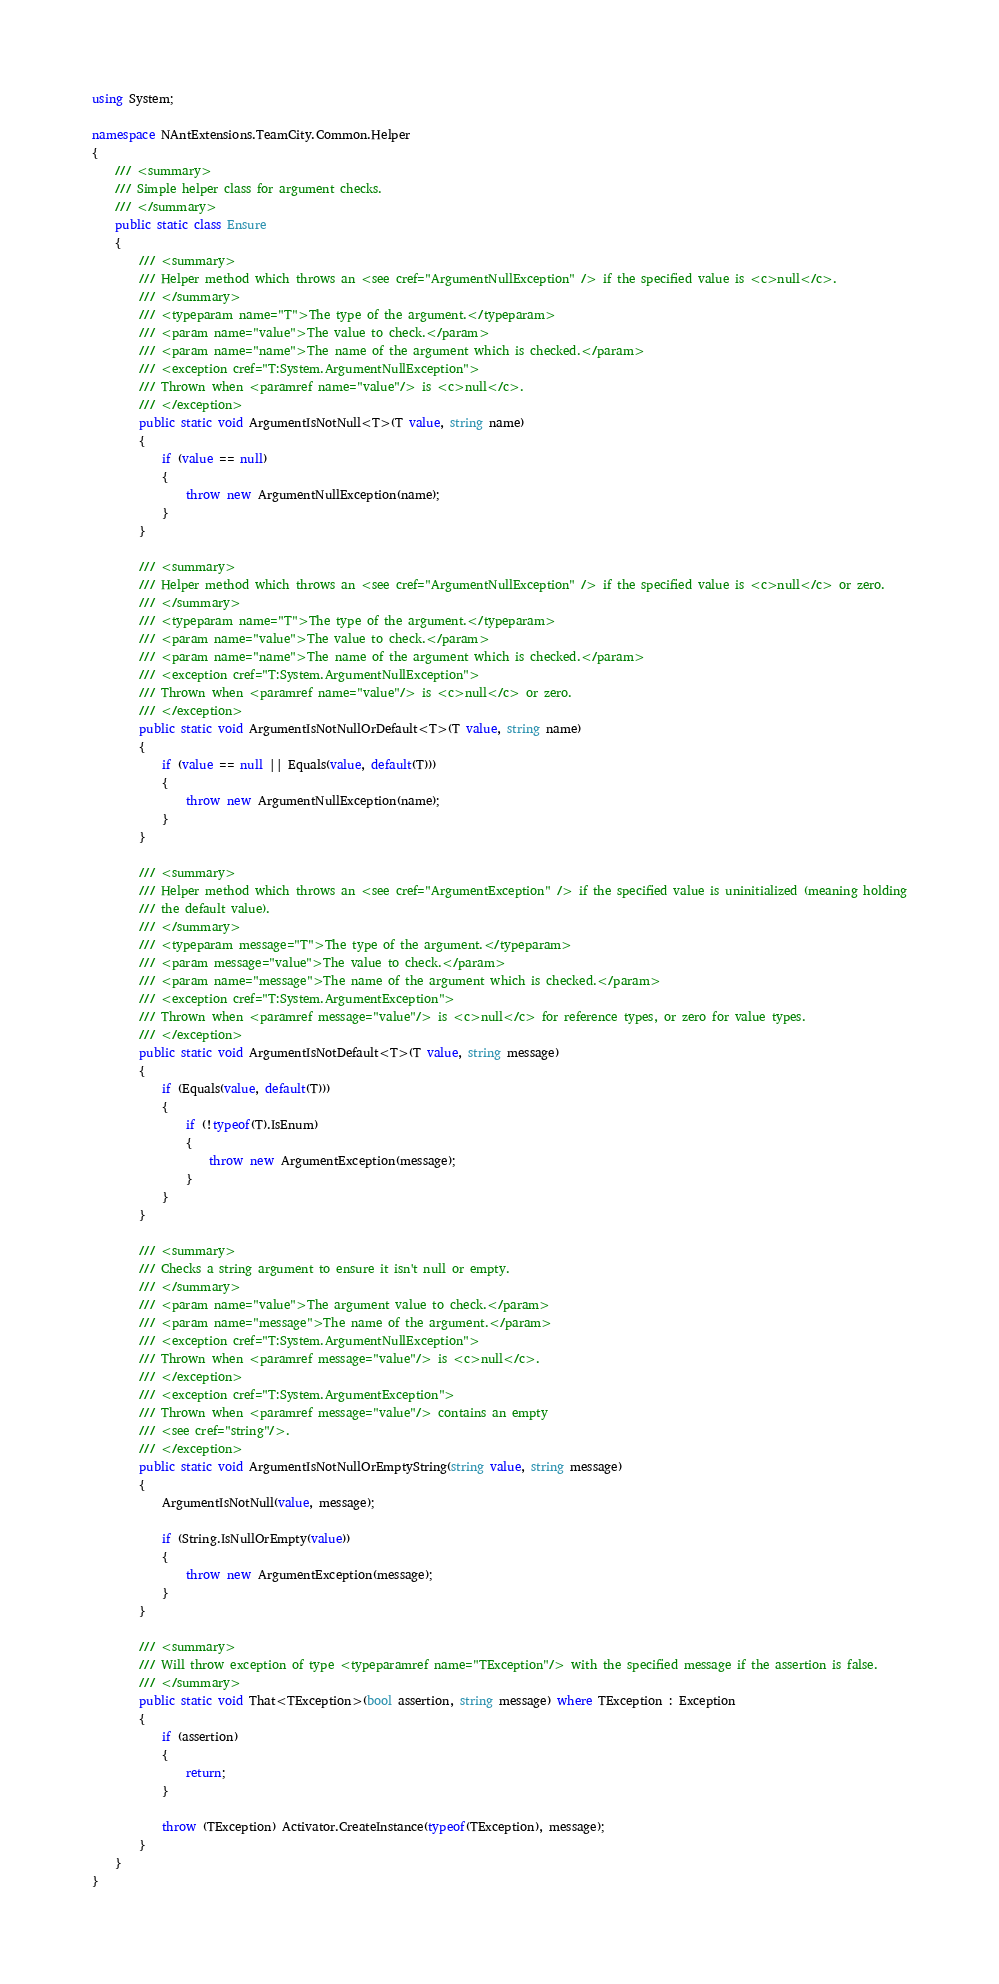<code> <loc_0><loc_0><loc_500><loc_500><_C#_>using System;

namespace NAntExtensions.TeamCity.Common.Helper
{
	/// <summary>
	/// Simple helper class for argument checks.
	/// </summary>
	public static class Ensure
	{
		/// <summary>
		/// Helper method which throws an <see cref="ArgumentNullException" /> if the specified value is <c>null</c>.
		/// </summary>
		/// <typeparam name="T">The type of the argument.</typeparam>
		/// <param name="value">The value to check.</param>
		/// <param name="name">The name of the argument which is checked.</param>
		/// <exception cref="T:System.ArgumentNullException">
		/// Thrown when <paramref name="value"/> is <c>null</c>.
		/// </exception>
		public static void ArgumentIsNotNull<T>(T value, string name)
		{
			if (value == null)
			{
				throw new ArgumentNullException(name);
			}
		}

		/// <summary>
		/// Helper method which throws an <see cref="ArgumentNullException" /> if the specified value is <c>null</c> or zero.
		/// </summary>
		/// <typeparam name="T">The type of the argument.</typeparam>
		/// <param name="value">The value to check.</param>
		/// <param name="name">The name of the argument which is checked.</param>
		/// <exception cref="T:System.ArgumentNullException">
		/// Thrown when <paramref name="value"/> is <c>null</c> or zero.
		/// </exception>
		public static void ArgumentIsNotNullOrDefault<T>(T value, string name)
		{
			if (value == null || Equals(value, default(T)))
			{
				throw new ArgumentNullException(name);
			}
		}

		/// <summary>
		/// Helper method which throws an <see cref="ArgumentException" /> if the specified value is uninitialized (meaning holding
		/// the default value).
		/// </summary>
		/// <typeparam message="T">The type of the argument.</typeparam>
		/// <param message="value">The value to check.</param>
		/// <param name="message">The name of the argument which is checked.</param>
		/// <exception cref="T:System.ArgumentException">
		/// Thrown when <paramref message="value"/> is <c>null</c> for reference types, or zero for value types.
		/// </exception>
		public static void ArgumentIsNotDefault<T>(T value, string message)
		{
			if (Equals(value, default(T)))
			{
				if (!typeof(T).IsEnum)
				{
					throw new ArgumentException(message);
				}
			}
		}

		/// <summary>
		/// Checks a string argument to ensure it isn't null or empty.
		/// </summary>
		/// <param name="value">The argument value to check.</param>
		/// <param name="message">The name of the argument.</param>
		/// <exception cref="T:System.ArgumentNullException">
		/// Thrown when <paramref message="value"/> is <c>null</c>.
		/// </exception>
		/// <exception cref="T:System.ArgumentException">
		/// Thrown when <paramref message="value"/> contains an empty 
		/// <see cref="string"/>.
		/// </exception>
		public static void ArgumentIsNotNullOrEmptyString(string value, string message)
		{
			ArgumentIsNotNull(value, message);

			if (String.IsNullOrEmpty(value))
			{
				throw new ArgumentException(message);
			}
		}

		/// <summary>
		/// Will throw exception of type <typeparamref name="TException"/> with the specified message if the assertion is false.
		/// </summary>
		public static void That<TException>(bool assertion, string message) where TException : Exception
		{
			if (assertion)
			{
				return;
			}

			throw (TException) Activator.CreateInstance(typeof(TException), message);
		}
	}
}</code> 